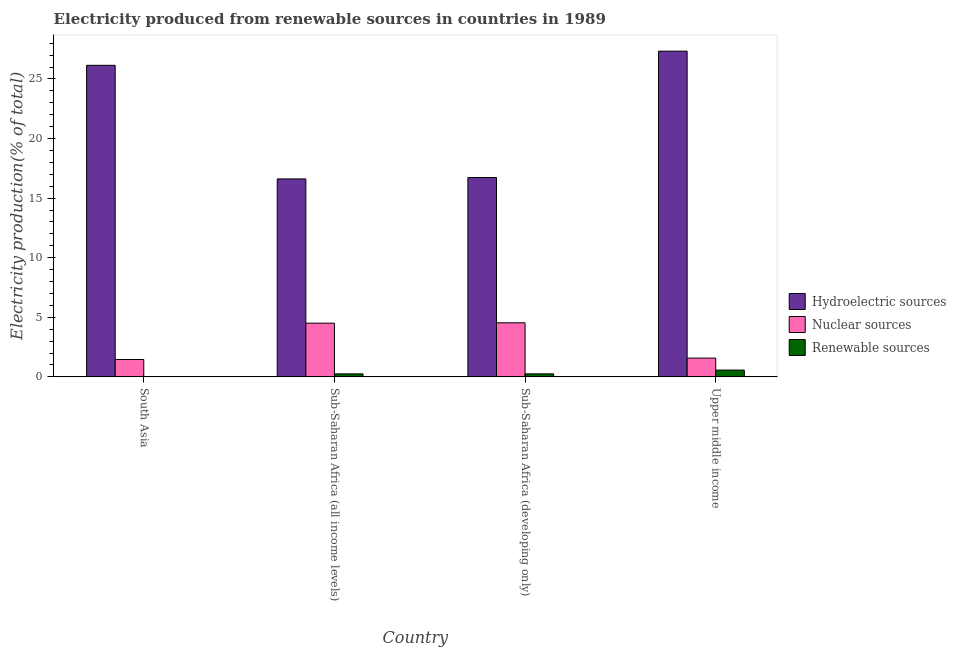How many groups of bars are there?
Offer a terse response. 4. Are the number of bars per tick equal to the number of legend labels?
Provide a succinct answer. Yes. Are the number of bars on each tick of the X-axis equal?
Your answer should be very brief. Yes. How many bars are there on the 3rd tick from the left?
Your response must be concise. 3. What is the label of the 4th group of bars from the left?
Keep it short and to the point. Upper middle income. In how many cases, is the number of bars for a given country not equal to the number of legend labels?
Make the answer very short. 0. What is the percentage of electricity produced by renewable sources in Sub-Saharan Africa (developing only)?
Offer a terse response. 0.25. Across all countries, what is the maximum percentage of electricity produced by nuclear sources?
Ensure brevity in your answer.  4.54. Across all countries, what is the minimum percentage of electricity produced by nuclear sources?
Offer a terse response. 1.46. In which country was the percentage of electricity produced by nuclear sources maximum?
Offer a very short reply. Sub-Saharan Africa (developing only). In which country was the percentage of electricity produced by renewable sources minimum?
Your response must be concise. South Asia. What is the total percentage of electricity produced by hydroelectric sources in the graph?
Your response must be concise. 86.82. What is the difference between the percentage of electricity produced by renewable sources in Sub-Saharan Africa (developing only) and that in Upper middle income?
Your answer should be very brief. -0.32. What is the difference between the percentage of electricity produced by renewable sources in Sub-Saharan Africa (all income levels) and the percentage of electricity produced by nuclear sources in Sub-Saharan Africa (developing only)?
Offer a very short reply. -4.29. What is the average percentage of electricity produced by hydroelectric sources per country?
Offer a very short reply. 21.7. What is the difference between the percentage of electricity produced by renewable sources and percentage of electricity produced by hydroelectric sources in Upper middle income?
Make the answer very short. -26.76. What is the ratio of the percentage of electricity produced by renewable sources in South Asia to that in Sub-Saharan Africa (all income levels)?
Your response must be concise. 0.01. Is the percentage of electricity produced by hydroelectric sources in South Asia less than that in Sub-Saharan Africa (developing only)?
Your answer should be very brief. No. What is the difference between the highest and the second highest percentage of electricity produced by renewable sources?
Your answer should be very brief. 0.32. What is the difference between the highest and the lowest percentage of electricity produced by renewable sources?
Your answer should be very brief. 0.57. Is the sum of the percentage of electricity produced by hydroelectric sources in Sub-Saharan Africa (all income levels) and Sub-Saharan Africa (developing only) greater than the maximum percentage of electricity produced by nuclear sources across all countries?
Keep it short and to the point. Yes. What does the 2nd bar from the left in Sub-Saharan Africa (developing only) represents?
Your answer should be very brief. Nuclear sources. What does the 1st bar from the right in Sub-Saharan Africa (all income levels) represents?
Your response must be concise. Renewable sources. What is the difference between two consecutive major ticks on the Y-axis?
Give a very brief answer. 5. How many legend labels are there?
Your answer should be very brief. 3. How are the legend labels stacked?
Ensure brevity in your answer.  Vertical. What is the title of the graph?
Your answer should be compact. Electricity produced from renewable sources in countries in 1989. What is the label or title of the X-axis?
Offer a very short reply. Country. What is the Electricity production(% of total) in Hydroelectric sources in South Asia?
Offer a very short reply. 26.14. What is the Electricity production(% of total) in Nuclear sources in South Asia?
Offer a terse response. 1.46. What is the Electricity production(% of total) of Renewable sources in South Asia?
Give a very brief answer. 0. What is the Electricity production(% of total) of Hydroelectric sources in Sub-Saharan Africa (all income levels)?
Provide a succinct answer. 16.61. What is the Electricity production(% of total) in Nuclear sources in Sub-Saharan Africa (all income levels)?
Your answer should be very brief. 4.51. What is the Electricity production(% of total) in Renewable sources in Sub-Saharan Africa (all income levels)?
Give a very brief answer. 0.25. What is the Electricity production(% of total) of Hydroelectric sources in Sub-Saharan Africa (developing only)?
Offer a very short reply. 16.73. What is the Electricity production(% of total) in Nuclear sources in Sub-Saharan Africa (developing only)?
Offer a terse response. 4.54. What is the Electricity production(% of total) in Renewable sources in Sub-Saharan Africa (developing only)?
Provide a succinct answer. 0.25. What is the Electricity production(% of total) in Hydroelectric sources in Upper middle income?
Offer a terse response. 27.33. What is the Electricity production(% of total) of Nuclear sources in Upper middle income?
Give a very brief answer. 1.58. What is the Electricity production(% of total) in Renewable sources in Upper middle income?
Your answer should be compact. 0.57. Across all countries, what is the maximum Electricity production(% of total) in Hydroelectric sources?
Offer a terse response. 27.33. Across all countries, what is the maximum Electricity production(% of total) of Nuclear sources?
Offer a terse response. 4.54. Across all countries, what is the maximum Electricity production(% of total) in Renewable sources?
Offer a terse response. 0.57. Across all countries, what is the minimum Electricity production(% of total) of Hydroelectric sources?
Ensure brevity in your answer.  16.61. Across all countries, what is the minimum Electricity production(% of total) in Nuclear sources?
Ensure brevity in your answer.  1.46. Across all countries, what is the minimum Electricity production(% of total) of Renewable sources?
Keep it short and to the point. 0. What is the total Electricity production(% of total) of Hydroelectric sources in the graph?
Make the answer very short. 86.82. What is the total Electricity production(% of total) of Nuclear sources in the graph?
Make the answer very short. 12.08. What is the total Electricity production(% of total) of Renewable sources in the graph?
Make the answer very short. 1.07. What is the difference between the Electricity production(% of total) in Hydroelectric sources in South Asia and that in Sub-Saharan Africa (all income levels)?
Your answer should be compact. 9.53. What is the difference between the Electricity production(% of total) of Nuclear sources in South Asia and that in Sub-Saharan Africa (all income levels)?
Provide a short and direct response. -3.05. What is the difference between the Electricity production(% of total) in Renewable sources in South Asia and that in Sub-Saharan Africa (all income levels)?
Your answer should be compact. -0.25. What is the difference between the Electricity production(% of total) of Hydroelectric sources in South Asia and that in Sub-Saharan Africa (developing only)?
Offer a very short reply. 9.42. What is the difference between the Electricity production(% of total) in Nuclear sources in South Asia and that in Sub-Saharan Africa (developing only)?
Offer a terse response. -3.08. What is the difference between the Electricity production(% of total) in Renewable sources in South Asia and that in Sub-Saharan Africa (developing only)?
Give a very brief answer. -0.25. What is the difference between the Electricity production(% of total) in Hydroelectric sources in South Asia and that in Upper middle income?
Ensure brevity in your answer.  -1.19. What is the difference between the Electricity production(% of total) of Nuclear sources in South Asia and that in Upper middle income?
Offer a terse response. -0.12. What is the difference between the Electricity production(% of total) of Renewable sources in South Asia and that in Upper middle income?
Your response must be concise. -0.57. What is the difference between the Electricity production(% of total) in Hydroelectric sources in Sub-Saharan Africa (all income levels) and that in Sub-Saharan Africa (developing only)?
Your answer should be very brief. -0.12. What is the difference between the Electricity production(% of total) of Nuclear sources in Sub-Saharan Africa (all income levels) and that in Sub-Saharan Africa (developing only)?
Keep it short and to the point. -0.03. What is the difference between the Electricity production(% of total) of Renewable sources in Sub-Saharan Africa (all income levels) and that in Sub-Saharan Africa (developing only)?
Your answer should be very brief. -0. What is the difference between the Electricity production(% of total) of Hydroelectric sources in Sub-Saharan Africa (all income levels) and that in Upper middle income?
Your answer should be compact. -10.72. What is the difference between the Electricity production(% of total) in Nuclear sources in Sub-Saharan Africa (all income levels) and that in Upper middle income?
Provide a short and direct response. 2.93. What is the difference between the Electricity production(% of total) of Renewable sources in Sub-Saharan Africa (all income levels) and that in Upper middle income?
Make the answer very short. -0.32. What is the difference between the Electricity production(% of total) of Hydroelectric sources in Sub-Saharan Africa (developing only) and that in Upper middle income?
Ensure brevity in your answer.  -10.6. What is the difference between the Electricity production(% of total) of Nuclear sources in Sub-Saharan Africa (developing only) and that in Upper middle income?
Provide a succinct answer. 2.96. What is the difference between the Electricity production(% of total) of Renewable sources in Sub-Saharan Africa (developing only) and that in Upper middle income?
Your answer should be very brief. -0.32. What is the difference between the Electricity production(% of total) in Hydroelectric sources in South Asia and the Electricity production(% of total) in Nuclear sources in Sub-Saharan Africa (all income levels)?
Keep it short and to the point. 21.64. What is the difference between the Electricity production(% of total) in Hydroelectric sources in South Asia and the Electricity production(% of total) in Renewable sources in Sub-Saharan Africa (all income levels)?
Offer a very short reply. 25.89. What is the difference between the Electricity production(% of total) of Nuclear sources in South Asia and the Electricity production(% of total) of Renewable sources in Sub-Saharan Africa (all income levels)?
Provide a short and direct response. 1.21. What is the difference between the Electricity production(% of total) of Hydroelectric sources in South Asia and the Electricity production(% of total) of Nuclear sources in Sub-Saharan Africa (developing only)?
Your response must be concise. 21.61. What is the difference between the Electricity production(% of total) of Hydroelectric sources in South Asia and the Electricity production(% of total) of Renewable sources in Sub-Saharan Africa (developing only)?
Your response must be concise. 25.89. What is the difference between the Electricity production(% of total) in Nuclear sources in South Asia and the Electricity production(% of total) in Renewable sources in Sub-Saharan Africa (developing only)?
Ensure brevity in your answer.  1.2. What is the difference between the Electricity production(% of total) in Hydroelectric sources in South Asia and the Electricity production(% of total) in Nuclear sources in Upper middle income?
Your answer should be compact. 24.57. What is the difference between the Electricity production(% of total) in Hydroelectric sources in South Asia and the Electricity production(% of total) in Renewable sources in Upper middle income?
Provide a succinct answer. 25.57. What is the difference between the Electricity production(% of total) in Nuclear sources in South Asia and the Electricity production(% of total) in Renewable sources in Upper middle income?
Make the answer very short. 0.89. What is the difference between the Electricity production(% of total) in Hydroelectric sources in Sub-Saharan Africa (all income levels) and the Electricity production(% of total) in Nuclear sources in Sub-Saharan Africa (developing only)?
Ensure brevity in your answer.  12.07. What is the difference between the Electricity production(% of total) in Hydroelectric sources in Sub-Saharan Africa (all income levels) and the Electricity production(% of total) in Renewable sources in Sub-Saharan Africa (developing only)?
Keep it short and to the point. 16.36. What is the difference between the Electricity production(% of total) of Nuclear sources in Sub-Saharan Africa (all income levels) and the Electricity production(% of total) of Renewable sources in Sub-Saharan Africa (developing only)?
Your response must be concise. 4.25. What is the difference between the Electricity production(% of total) in Hydroelectric sources in Sub-Saharan Africa (all income levels) and the Electricity production(% of total) in Nuclear sources in Upper middle income?
Provide a short and direct response. 15.04. What is the difference between the Electricity production(% of total) in Hydroelectric sources in Sub-Saharan Africa (all income levels) and the Electricity production(% of total) in Renewable sources in Upper middle income?
Ensure brevity in your answer.  16.04. What is the difference between the Electricity production(% of total) of Nuclear sources in Sub-Saharan Africa (all income levels) and the Electricity production(% of total) of Renewable sources in Upper middle income?
Keep it short and to the point. 3.94. What is the difference between the Electricity production(% of total) of Hydroelectric sources in Sub-Saharan Africa (developing only) and the Electricity production(% of total) of Nuclear sources in Upper middle income?
Offer a very short reply. 15.15. What is the difference between the Electricity production(% of total) of Hydroelectric sources in Sub-Saharan Africa (developing only) and the Electricity production(% of total) of Renewable sources in Upper middle income?
Provide a succinct answer. 16.16. What is the difference between the Electricity production(% of total) in Nuclear sources in Sub-Saharan Africa (developing only) and the Electricity production(% of total) in Renewable sources in Upper middle income?
Make the answer very short. 3.97. What is the average Electricity production(% of total) in Hydroelectric sources per country?
Your answer should be compact. 21.7. What is the average Electricity production(% of total) of Nuclear sources per country?
Give a very brief answer. 3.02. What is the average Electricity production(% of total) of Renewable sources per country?
Make the answer very short. 0.27. What is the difference between the Electricity production(% of total) in Hydroelectric sources and Electricity production(% of total) in Nuclear sources in South Asia?
Your answer should be compact. 24.69. What is the difference between the Electricity production(% of total) in Hydroelectric sources and Electricity production(% of total) in Renewable sources in South Asia?
Give a very brief answer. 26.14. What is the difference between the Electricity production(% of total) in Nuclear sources and Electricity production(% of total) in Renewable sources in South Asia?
Provide a short and direct response. 1.46. What is the difference between the Electricity production(% of total) of Hydroelectric sources and Electricity production(% of total) of Nuclear sources in Sub-Saharan Africa (all income levels)?
Your answer should be very brief. 12.11. What is the difference between the Electricity production(% of total) of Hydroelectric sources and Electricity production(% of total) of Renewable sources in Sub-Saharan Africa (all income levels)?
Make the answer very short. 16.36. What is the difference between the Electricity production(% of total) of Nuclear sources and Electricity production(% of total) of Renewable sources in Sub-Saharan Africa (all income levels)?
Provide a succinct answer. 4.26. What is the difference between the Electricity production(% of total) of Hydroelectric sources and Electricity production(% of total) of Nuclear sources in Sub-Saharan Africa (developing only)?
Your answer should be very brief. 12.19. What is the difference between the Electricity production(% of total) of Hydroelectric sources and Electricity production(% of total) of Renewable sources in Sub-Saharan Africa (developing only)?
Your answer should be compact. 16.48. What is the difference between the Electricity production(% of total) in Nuclear sources and Electricity production(% of total) in Renewable sources in Sub-Saharan Africa (developing only)?
Ensure brevity in your answer.  4.29. What is the difference between the Electricity production(% of total) of Hydroelectric sources and Electricity production(% of total) of Nuclear sources in Upper middle income?
Offer a very short reply. 25.76. What is the difference between the Electricity production(% of total) of Hydroelectric sources and Electricity production(% of total) of Renewable sources in Upper middle income?
Offer a terse response. 26.76. What is the ratio of the Electricity production(% of total) of Hydroelectric sources in South Asia to that in Sub-Saharan Africa (all income levels)?
Your answer should be very brief. 1.57. What is the ratio of the Electricity production(% of total) in Nuclear sources in South Asia to that in Sub-Saharan Africa (all income levels)?
Ensure brevity in your answer.  0.32. What is the ratio of the Electricity production(% of total) in Renewable sources in South Asia to that in Sub-Saharan Africa (all income levels)?
Make the answer very short. 0.01. What is the ratio of the Electricity production(% of total) in Hydroelectric sources in South Asia to that in Sub-Saharan Africa (developing only)?
Your answer should be very brief. 1.56. What is the ratio of the Electricity production(% of total) of Nuclear sources in South Asia to that in Sub-Saharan Africa (developing only)?
Your answer should be compact. 0.32. What is the ratio of the Electricity production(% of total) of Renewable sources in South Asia to that in Sub-Saharan Africa (developing only)?
Give a very brief answer. 0.01. What is the ratio of the Electricity production(% of total) of Hydroelectric sources in South Asia to that in Upper middle income?
Provide a short and direct response. 0.96. What is the ratio of the Electricity production(% of total) of Nuclear sources in South Asia to that in Upper middle income?
Keep it short and to the point. 0.92. What is the ratio of the Electricity production(% of total) of Renewable sources in South Asia to that in Upper middle income?
Make the answer very short. 0. What is the ratio of the Electricity production(% of total) of Hydroelectric sources in Sub-Saharan Africa (all income levels) to that in Sub-Saharan Africa (developing only)?
Ensure brevity in your answer.  0.99. What is the ratio of the Electricity production(% of total) of Hydroelectric sources in Sub-Saharan Africa (all income levels) to that in Upper middle income?
Keep it short and to the point. 0.61. What is the ratio of the Electricity production(% of total) in Nuclear sources in Sub-Saharan Africa (all income levels) to that in Upper middle income?
Your answer should be compact. 2.86. What is the ratio of the Electricity production(% of total) of Renewable sources in Sub-Saharan Africa (all income levels) to that in Upper middle income?
Keep it short and to the point. 0.44. What is the ratio of the Electricity production(% of total) in Hydroelectric sources in Sub-Saharan Africa (developing only) to that in Upper middle income?
Ensure brevity in your answer.  0.61. What is the ratio of the Electricity production(% of total) of Nuclear sources in Sub-Saharan Africa (developing only) to that in Upper middle income?
Give a very brief answer. 2.88. What is the ratio of the Electricity production(% of total) of Renewable sources in Sub-Saharan Africa (developing only) to that in Upper middle income?
Provide a succinct answer. 0.44. What is the difference between the highest and the second highest Electricity production(% of total) in Hydroelectric sources?
Offer a terse response. 1.19. What is the difference between the highest and the second highest Electricity production(% of total) in Nuclear sources?
Your response must be concise. 0.03. What is the difference between the highest and the second highest Electricity production(% of total) in Renewable sources?
Your response must be concise. 0.32. What is the difference between the highest and the lowest Electricity production(% of total) of Hydroelectric sources?
Your answer should be compact. 10.72. What is the difference between the highest and the lowest Electricity production(% of total) in Nuclear sources?
Your answer should be very brief. 3.08. What is the difference between the highest and the lowest Electricity production(% of total) in Renewable sources?
Keep it short and to the point. 0.57. 